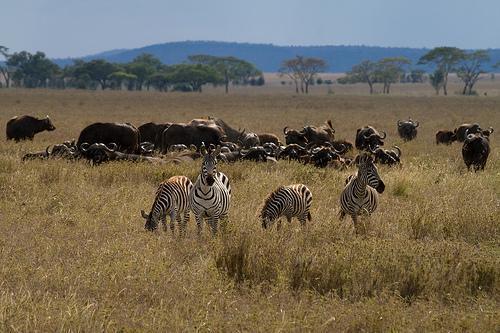How many zebras can you see?
Give a very brief answer. 4. How many kinds of animals can you see?
Give a very brief answer. 2. 